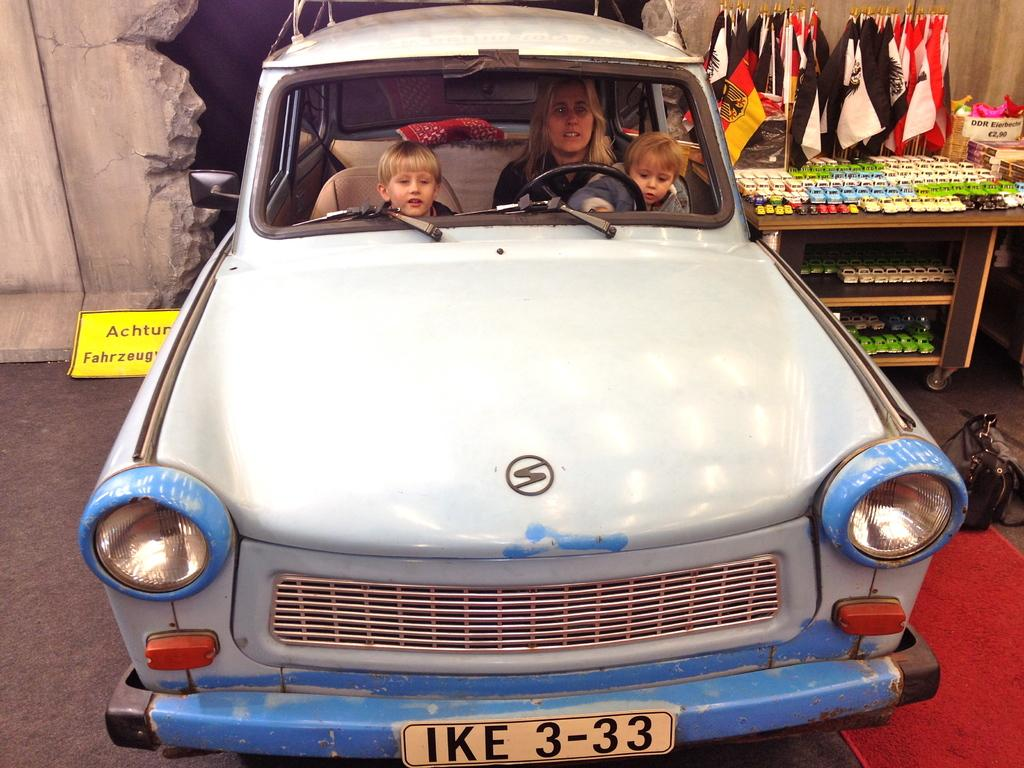Who is present in the image? There is a woman and two children in the image. What are they doing in the image? The woman and children are sitting in a car. What can be seen in the background of the image? There is a table in the background of the image, and it has toys on it. Are there any other objects or symbols visible in the image? Yes, there are flags visible in the image. What type of bead is used to cover the car in the image? There is no bead used to cover the car in the image; it is a regular car with the woman and children inside. 